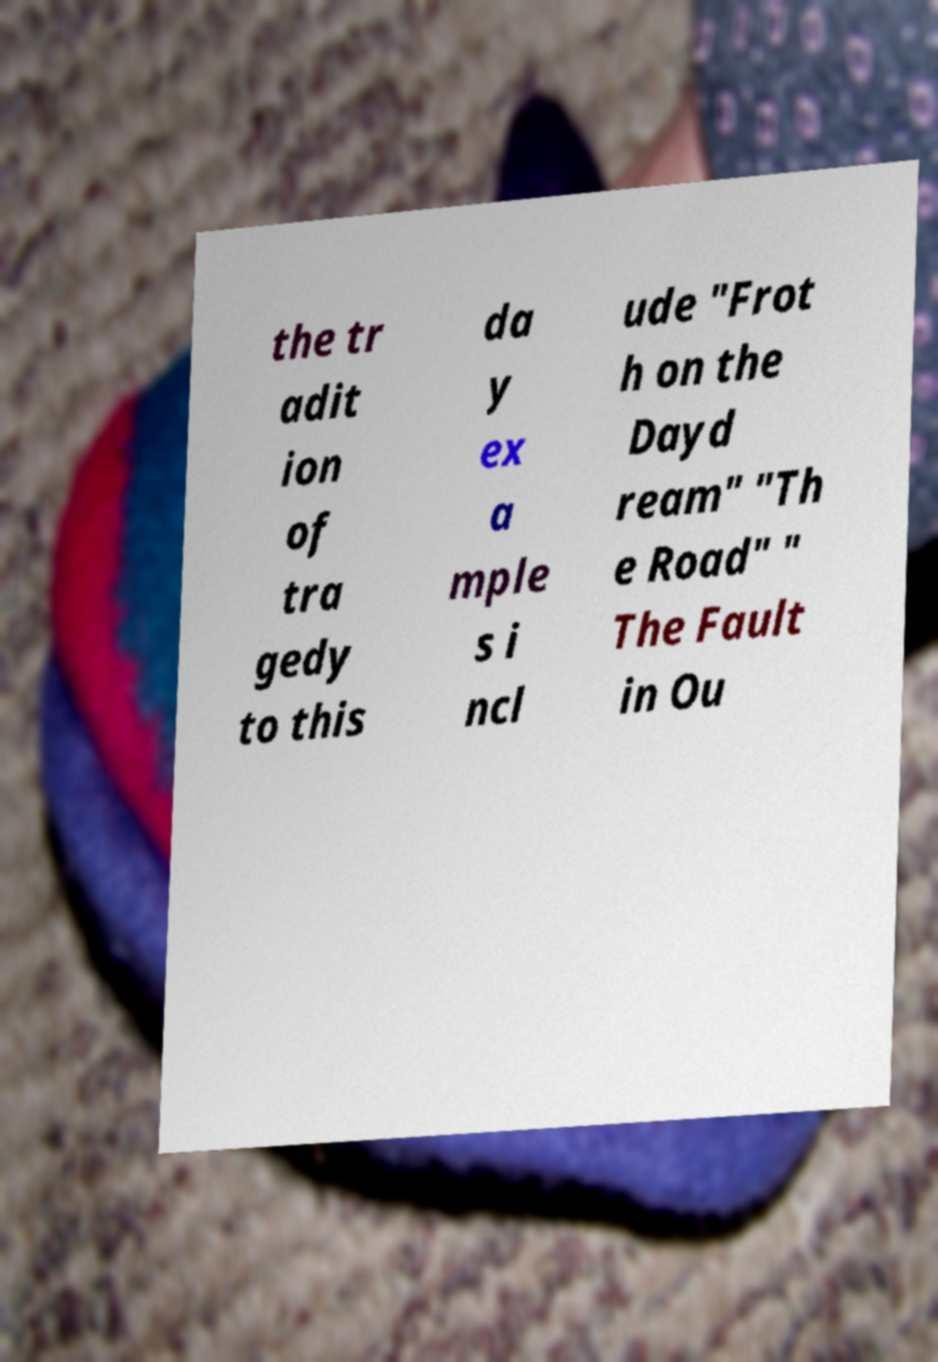What messages or text are displayed in this image? I need them in a readable, typed format. the tr adit ion of tra gedy to this da y ex a mple s i ncl ude "Frot h on the Dayd ream" "Th e Road" " The Fault in Ou 